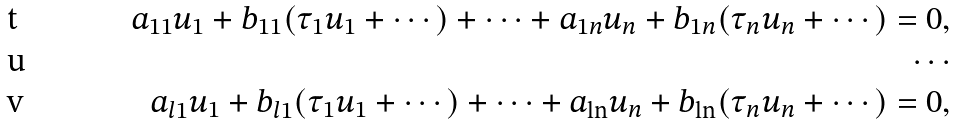<formula> <loc_0><loc_0><loc_500><loc_500>a _ { 1 1 } u _ { 1 } + b _ { 1 1 } ( \tau _ { 1 } u _ { 1 } + \cdots ) + \cdots + a _ { 1 n } u _ { n } + b _ { 1 n } ( \tau _ { n } u _ { n } + \cdots ) = 0 , \\ \cdots \\ a _ { l 1 } u _ { 1 } + b _ { l 1 } ( \tau _ { 1 } u _ { 1 } + \cdots ) + \cdots + a _ { \ln } u _ { n } + b _ { \ln } ( \tau _ { n } u _ { n } + \cdots ) = 0 ,</formula> 